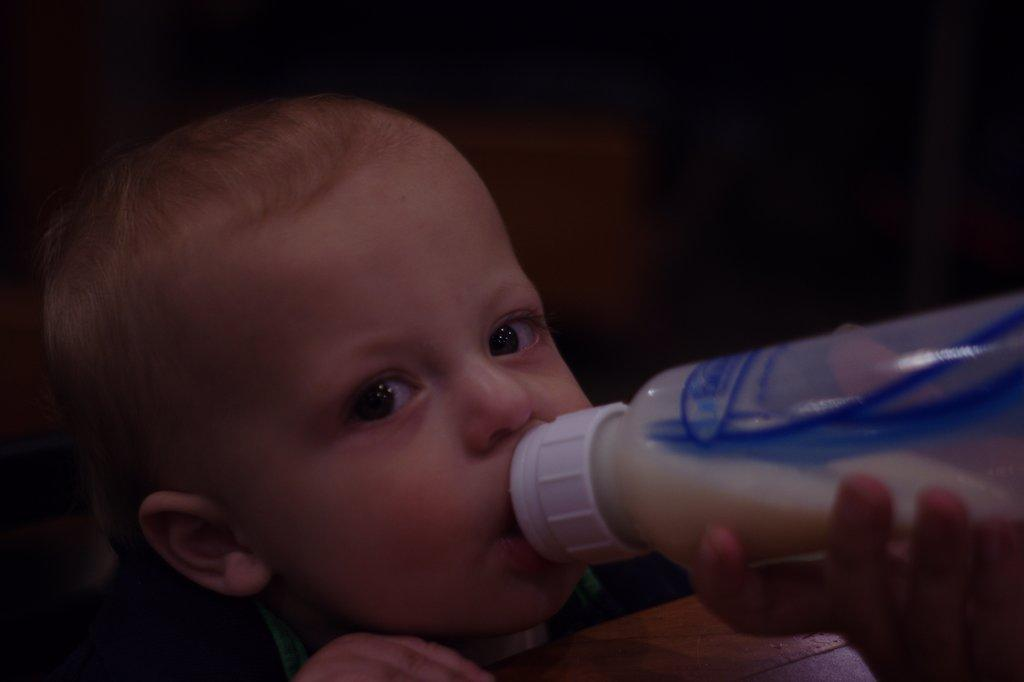What is the main subject of the image? There is a baby in the image. What is the baby doing in the image? The baby is drinking bottle milk. Whose hand is holding the bottle in the image? There is a hand holding the bottle in the bottom right of the image. What is the plot of the story unfolding in the image? There is no story or plot depicted in the image; it simply shows a baby drinking bottle milk. Can you see the moon in the image? The moon is not visible in the image; it only shows a baby drinking bottle milk and a hand holding the bottle. 